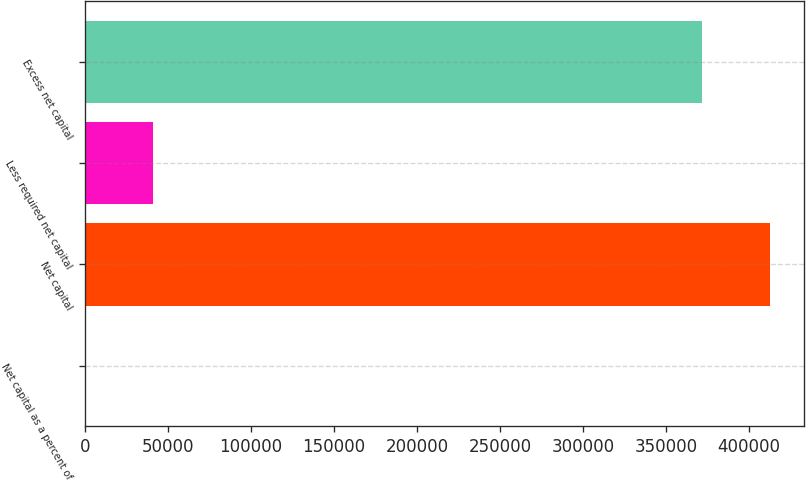Convert chart to OTSL. <chart><loc_0><loc_0><loc_500><loc_500><bar_chart><fcel>Net capital as a percent of<fcel>Net capital<fcel>Less required net capital<fcel>Excess net capital<nl><fcel>20.85<fcel>412890<fcel>41141<fcel>371770<nl></chart> 